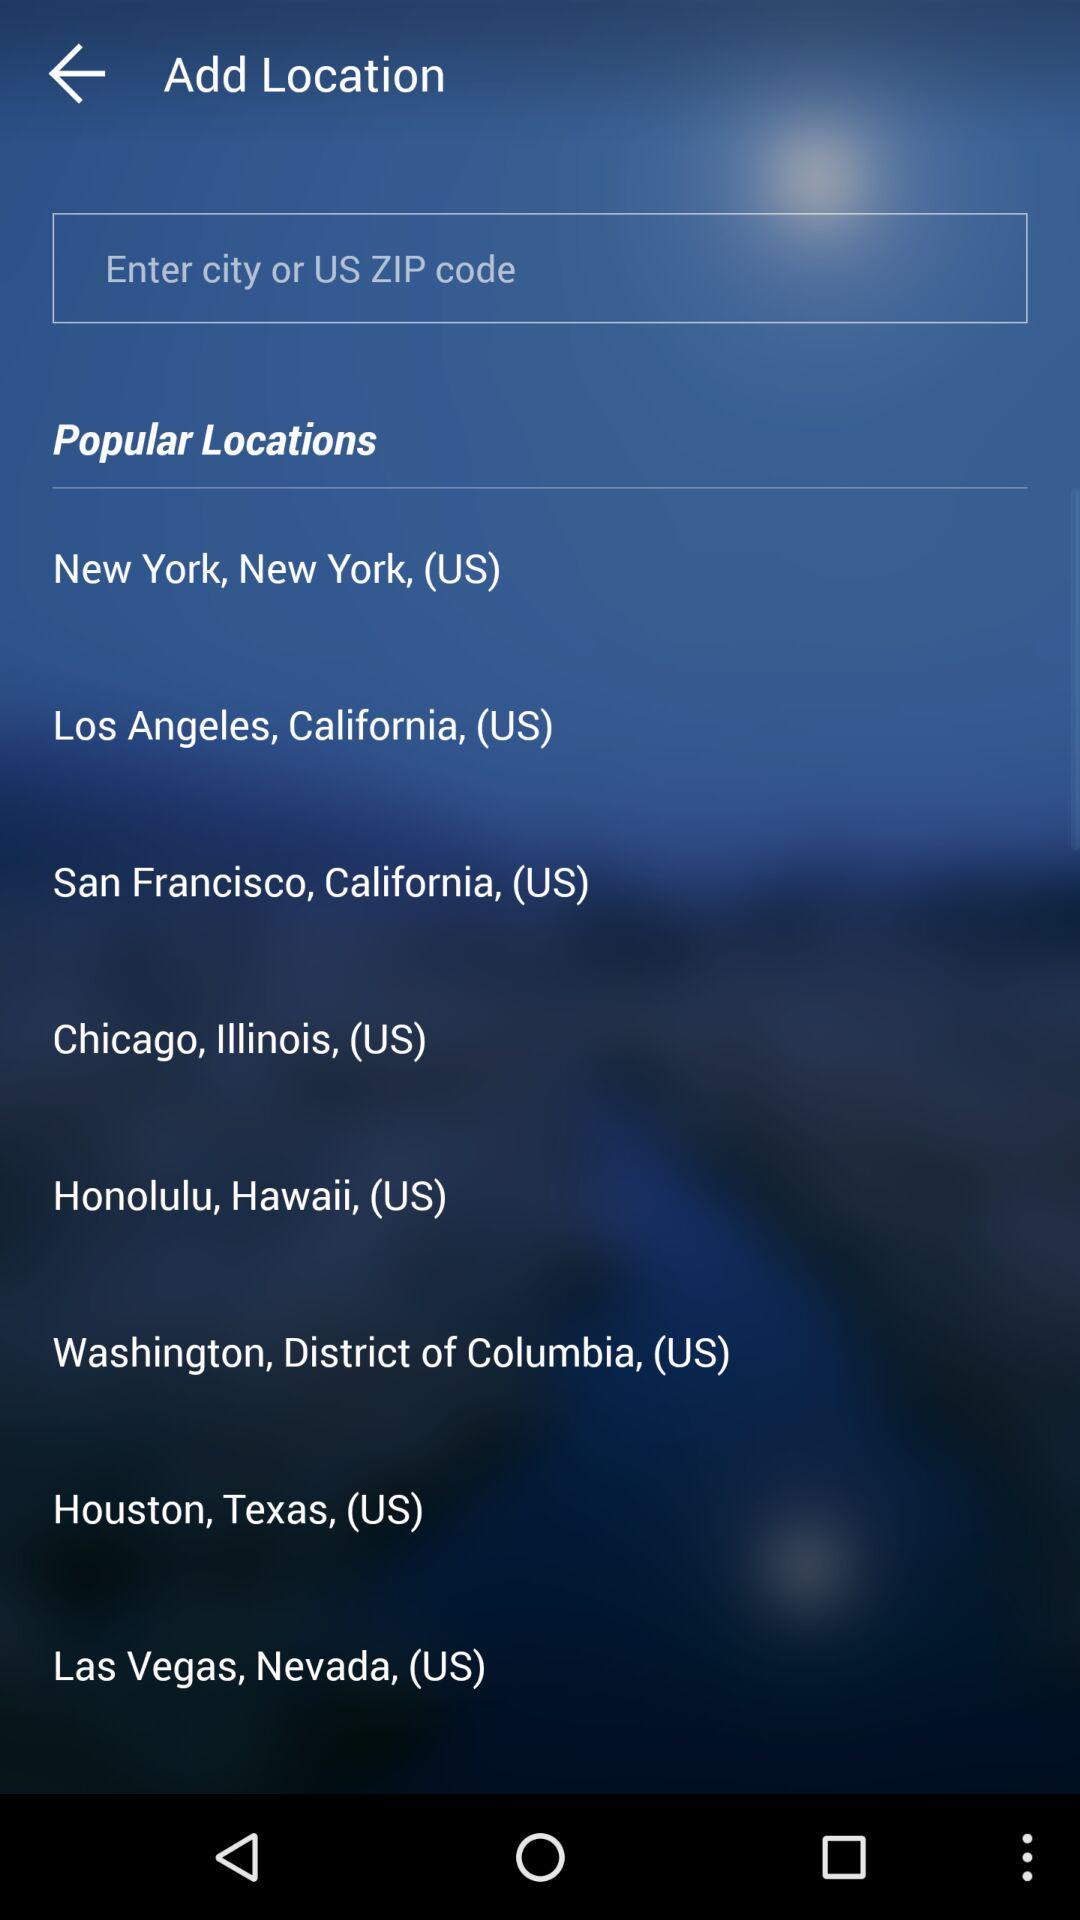Which country is mentioned? The mentioned country is the United States. 